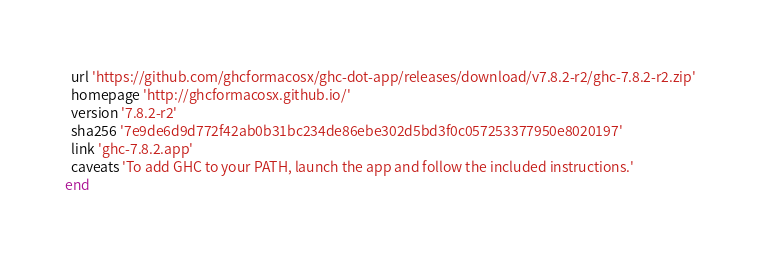Convert code to text. <code><loc_0><loc_0><loc_500><loc_500><_Ruby_>  url 'https://github.com/ghcformacosx/ghc-dot-app/releases/download/v7.8.2-r2/ghc-7.8.2-r2.zip'
  homepage 'http://ghcformacosx.github.io/'
  version '7.8.2-r2'
  sha256 '7e9de6d9d772f42ab0b31bc234de86ebe302d5bd3f0c057253377950e8020197'
  link 'ghc-7.8.2.app'
  caveats 'To add GHC to your PATH, launch the app and follow the included instructions.'
end
</code> 